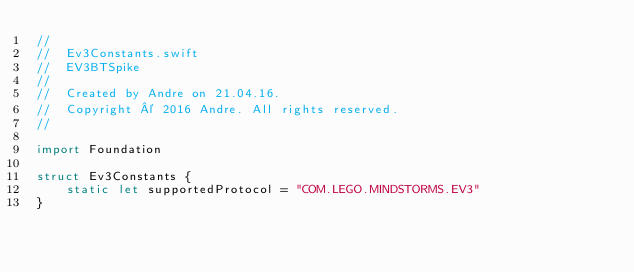Convert code to text. <code><loc_0><loc_0><loc_500><loc_500><_Swift_>//
//  Ev3Constants.swift
//  EV3BTSpike
//
//  Created by Andre on 21.04.16.
//  Copyright © 2016 Andre. All rights reserved.
//

import Foundation

struct Ev3Constants {
    static let supportedProtocol = "COM.LEGO.MINDSTORMS.EV3"    
}</code> 